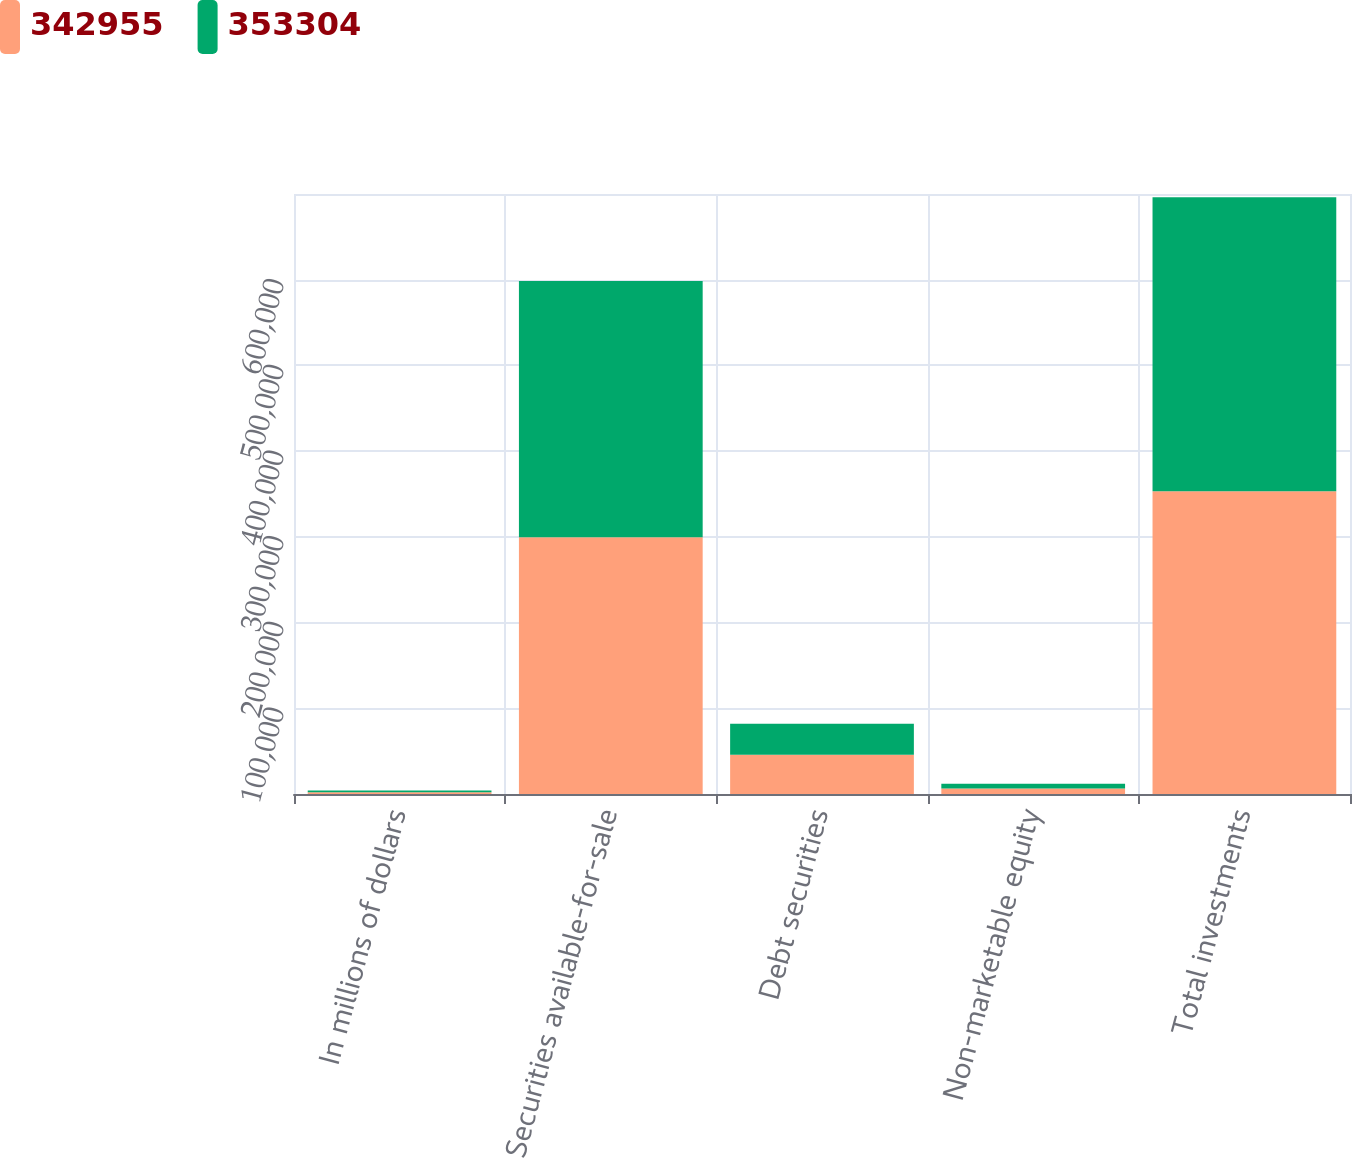Convert chart. <chart><loc_0><loc_0><loc_500><loc_500><stacked_bar_chart><ecel><fcel>In millions of dollars<fcel>Securities available-for-sale<fcel>Debt securities<fcel>Non-marketable equity<fcel>Total investments<nl><fcel>342955<fcel>2016<fcel>299424<fcel>45667<fcel>6439<fcel>353304<nl><fcel>353304<fcel>2015<fcel>299136<fcel>36215<fcel>5516<fcel>342955<nl></chart> 